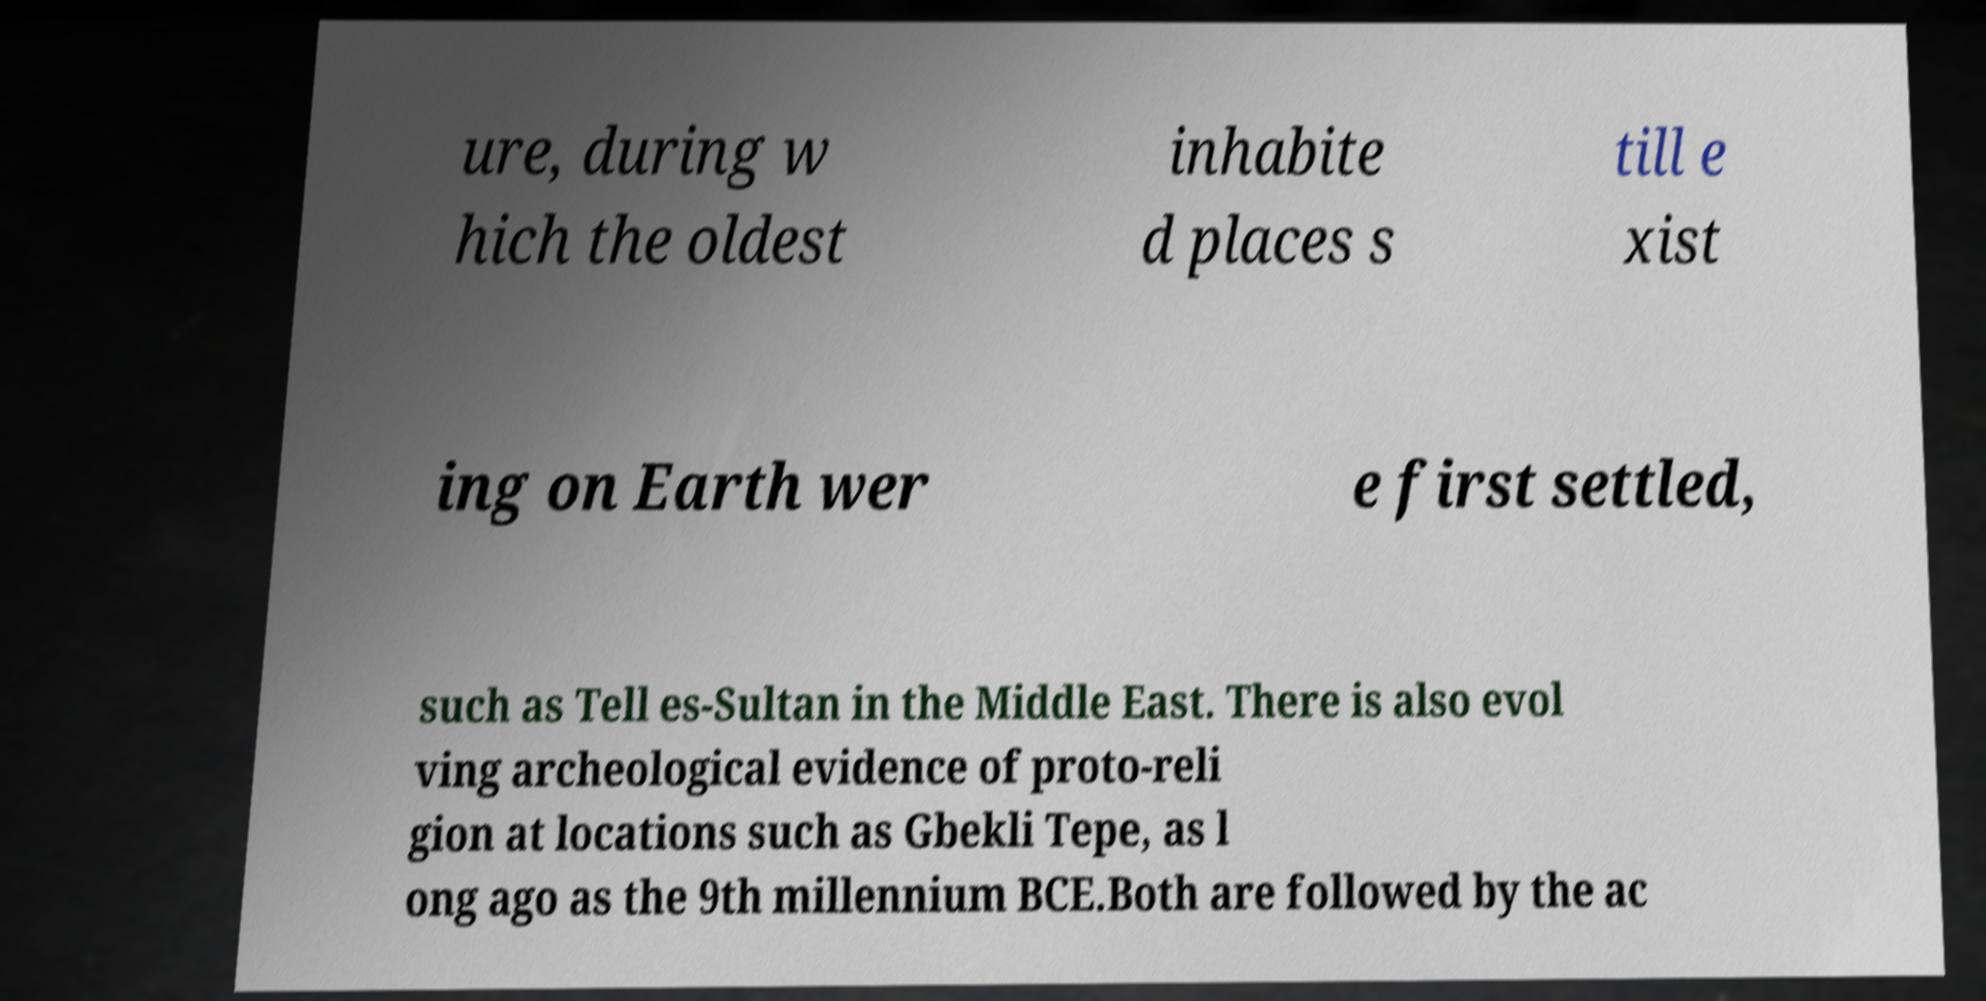Could you extract and type out the text from this image? ure, during w hich the oldest inhabite d places s till e xist ing on Earth wer e first settled, such as Tell es-Sultan in the Middle East. There is also evol ving archeological evidence of proto-reli gion at locations such as Gbekli Tepe, as l ong ago as the 9th millennium BCE.Both are followed by the ac 